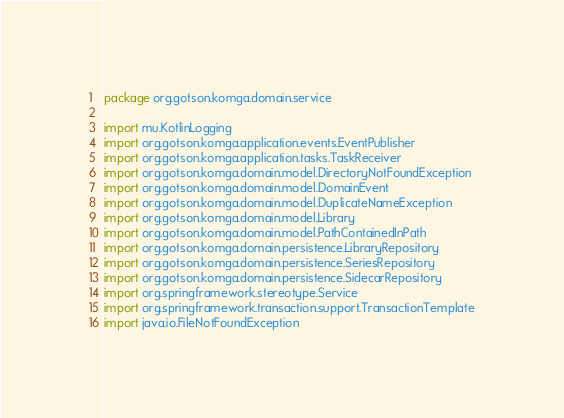<code> <loc_0><loc_0><loc_500><loc_500><_Kotlin_>package org.gotson.komga.domain.service

import mu.KotlinLogging
import org.gotson.komga.application.events.EventPublisher
import org.gotson.komga.application.tasks.TaskReceiver
import org.gotson.komga.domain.model.DirectoryNotFoundException
import org.gotson.komga.domain.model.DomainEvent
import org.gotson.komga.domain.model.DuplicateNameException
import org.gotson.komga.domain.model.Library
import org.gotson.komga.domain.model.PathContainedInPath
import org.gotson.komga.domain.persistence.LibraryRepository
import org.gotson.komga.domain.persistence.SeriesRepository
import org.gotson.komga.domain.persistence.SidecarRepository
import org.springframework.stereotype.Service
import org.springframework.transaction.support.TransactionTemplate
import java.io.FileNotFoundException</code> 